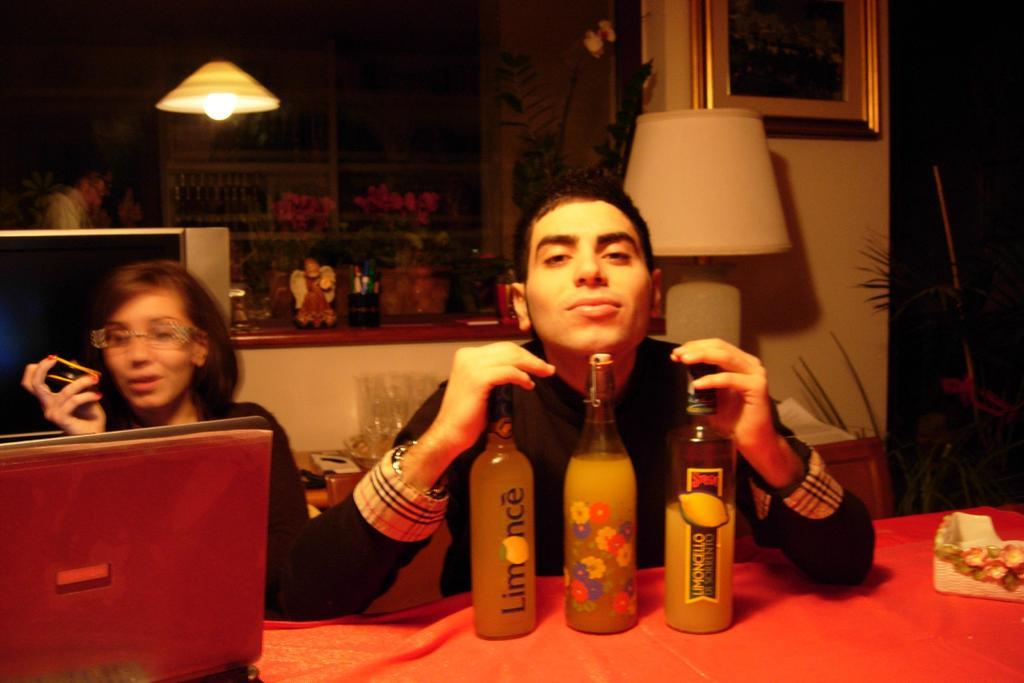What is the person in the image wearing? The person is wearing a black shirt in the image. What is the person holding in the image? The person is holding three glass bottles in the image. Where are the glass bottles placed? The glass bottles are placed on a table in the image. Who else is present in the image? There is a woman sitting in a chair beside the person. What type of camera can be seen in the picture? There is no camera present in the image. What is the stem of the picture used for? There is no picture or stem present in the image. 